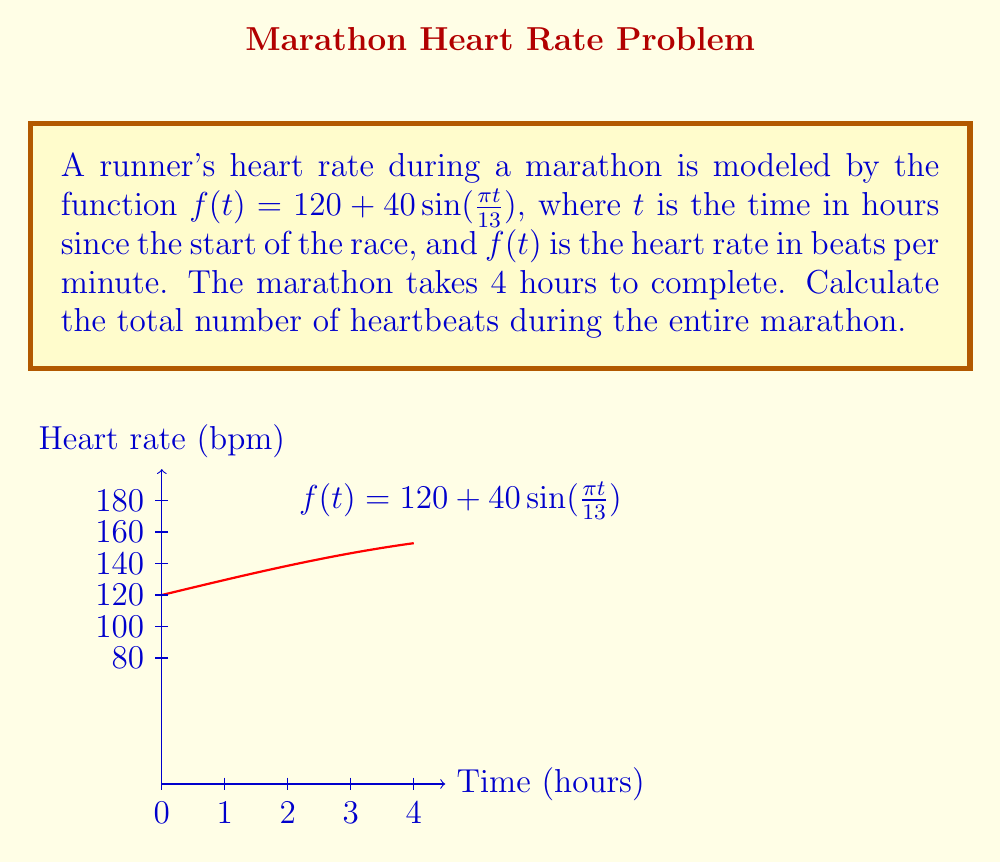Show me your answer to this math problem. To find the total number of heartbeats, we need to calculate the area under the curve of the heart rate function over the 4-hour period. This can be done using integration.

1) The function representing the heart rate is:
   $f(t) = 120 + 40\sin(\frac{\pi t}{13})$

2) We need to integrate this function from $t=0$ to $t=4$:
   $\int_0^4 [120 + 40\sin(\frac{\pi t}{13})] dt$

3) Let's split this into two integrals:
   $\int_0^4 120 dt + \int_0^4 40\sin(\frac{\pi t}{13}) dt$

4) The first integral is straightforward:
   $120t|_0^4 = 120 \cdot 4 = 480$

5) For the second integral, we use the substitution method:
   Let $u = \frac{\pi t}{13}$, then $du = \frac{\pi}{13} dt$, or $dt = \frac{13}{\pi} du$
   When $t=0$, $u=0$; when $t=4$, $u=\frac{4\pi}{13}$

6) The second integral becomes:
   $40 \cdot \frac{13}{\pi} \int_0^{\frac{4\pi}{13}} \sin(u) du$

7) Evaluate this:
   $40 \cdot \frac{13}{\pi} [-\cos(u)]_0^{\frac{4\pi}{13}}$
   $= \frac{520}{\pi} [-\cos(\frac{4\pi}{13}) + \cos(0)]$
   $= \frac{520}{\pi} [1 - \cos(\frac{4\pi}{13})]$

8) Add the results from steps 4 and 7:
   $480 + \frac{520}{\pi} [1 - \cos(\frac{4\pi}{13})]$

9) This gives the total area under the curve in beats per hour. To get the total number of heartbeats, we need to multiply by 60 (minutes per hour):

   Total heartbeats = $60 \cdot [480 + \frac{520}{\pi} (1 - \cos(\frac{4\pi}{13}))]$

10) Evaluating this numerically:
    Total heartbeats ≈ 28,818
Answer: 28,818 heartbeats 